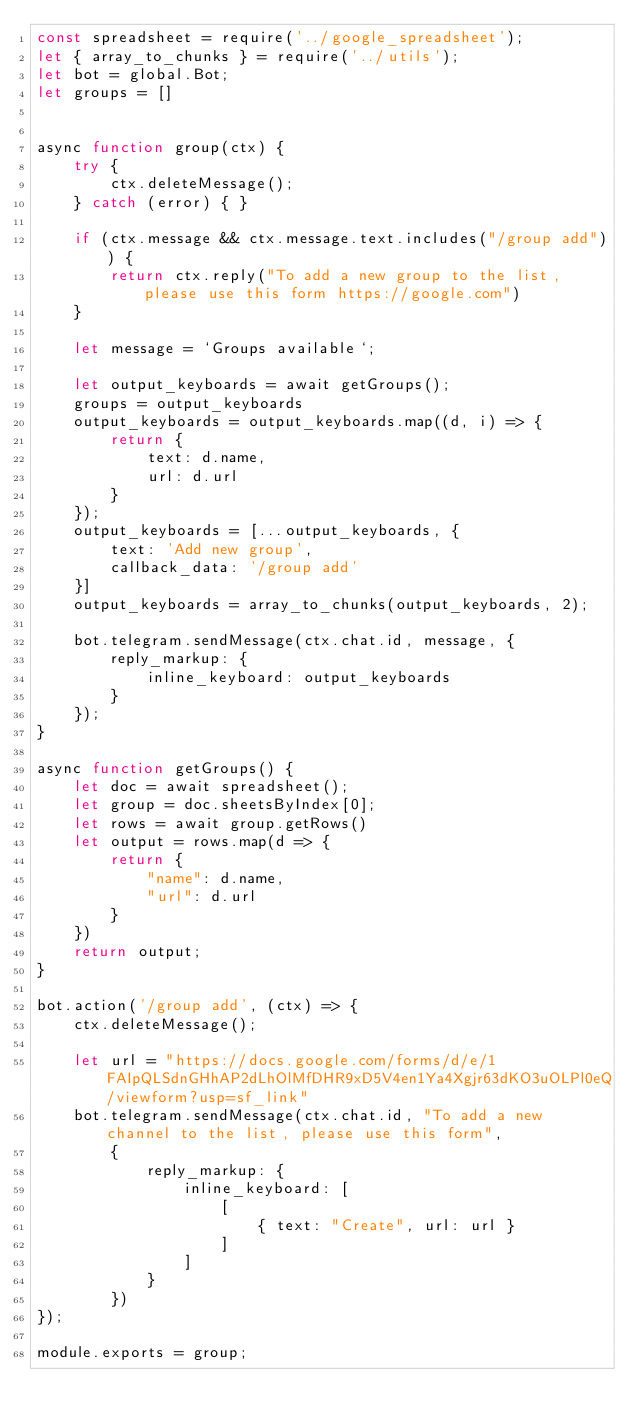Convert code to text. <code><loc_0><loc_0><loc_500><loc_500><_JavaScript_>const spreadsheet = require('../google_spreadsheet');
let { array_to_chunks } = require('../utils');
let bot = global.Bot;
let groups = []


async function group(ctx) {
    try {
        ctx.deleteMessage();
    } catch (error) { }

    if (ctx.message && ctx.message.text.includes("/group add")) {
        return ctx.reply("To add a new group to the list, please use this form https://google.com")
    }

    let message = `Groups available`;

    let output_keyboards = await getGroups();
    groups = output_keyboards
    output_keyboards = output_keyboards.map((d, i) => {
        return {
            text: d.name,
            url: d.url
        }
    });
    output_keyboards = [...output_keyboards, {
        text: 'Add new group',
        callback_data: '/group add'
    }]
    output_keyboards = array_to_chunks(output_keyboards, 2);

    bot.telegram.sendMessage(ctx.chat.id, message, {
        reply_markup: {
            inline_keyboard: output_keyboards
        }
    });
}

async function getGroups() {
    let doc = await spreadsheet();
    let group = doc.sheetsByIndex[0];
    let rows = await group.getRows()
    let output = rows.map(d => {
        return {
            "name": d.name,
            "url": d.url
        }
    })
    return output;
}

bot.action('/group add', (ctx) => {
    ctx.deleteMessage();

    let url = "https://docs.google.com/forms/d/e/1FAIpQLSdnGHhAP2dLhOlMfDHR9xD5V4en1Ya4Xgjr63dKO3uOLPl0eQ/viewform?usp=sf_link"
    bot.telegram.sendMessage(ctx.chat.id, "To add a new channel to the list, please use this form",
        {
            reply_markup: {
                inline_keyboard: [
                    [
                        { text: "Create", url: url }
                    ]
                ]
            }
        })
});

module.exports = group;</code> 